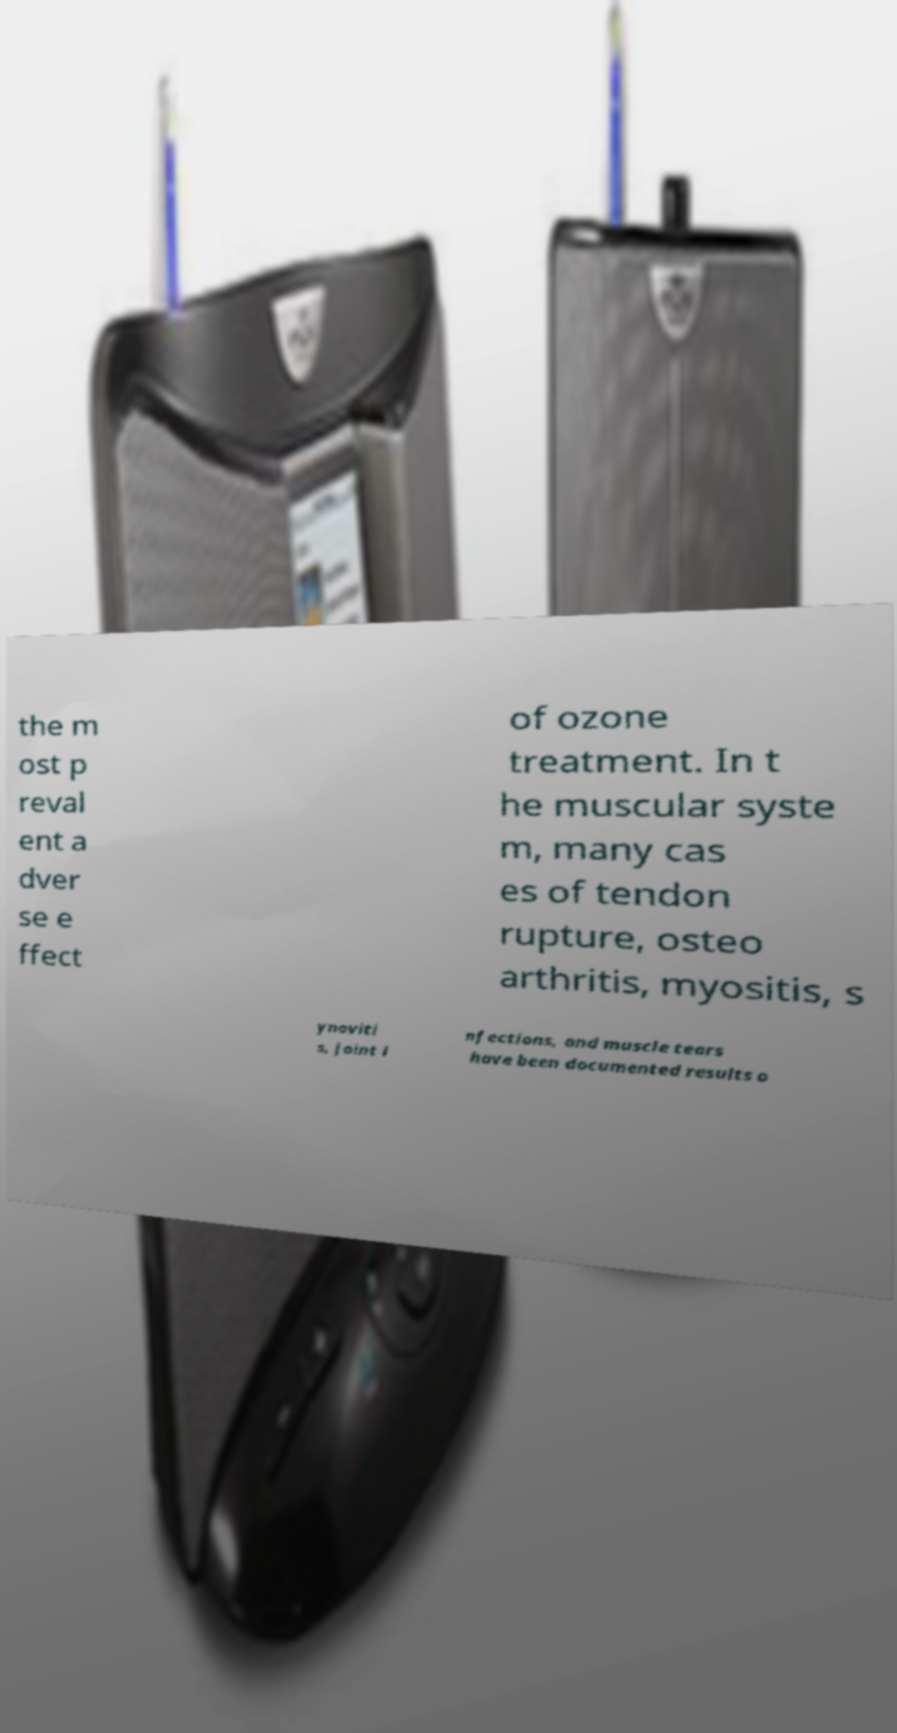I need the written content from this picture converted into text. Can you do that? the m ost p reval ent a dver se e ffect of ozone treatment. In t he muscular syste m, many cas es of tendon rupture, osteo arthritis, myositis, s ynoviti s, joint i nfections, and muscle tears have been documented results o 